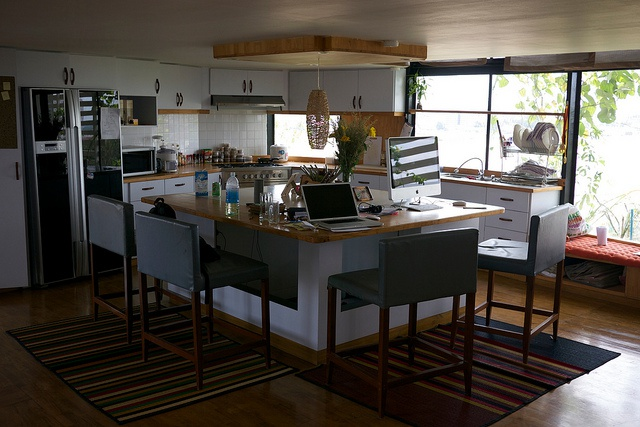Describe the objects in this image and their specific colors. I can see chair in black and gray tones, refrigerator in black, gray, and darkgray tones, chair in black and gray tones, chair in black, gray, darkgray, and maroon tones, and dining table in black, gray, and white tones in this image. 